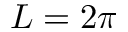<formula> <loc_0><loc_0><loc_500><loc_500>L = 2 \pi</formula> 